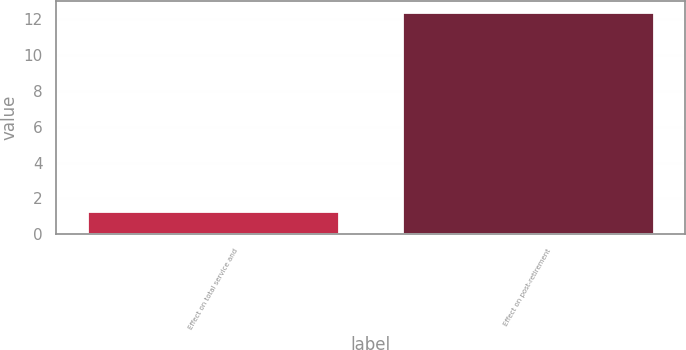Convert chart. <chart><loc_0><loc_0><loc_500><loc_500><bar_chart><fcel>Effect on total service and<fcel>Effect on post-retirement<nl><fcel>1.3<fcel>12.4<nl></chart> 